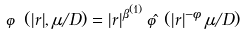Convert formula to latex. <formula><loc_0><loc_0><loc_500><loc_500>\varphi ( | r | , \mu / D ) = | r | ^ { \beta ^ { ( 1 ) } } \, { \hat { \varphi } } ( | r | ^ { - \phi } \, \mu / D )</formula> 